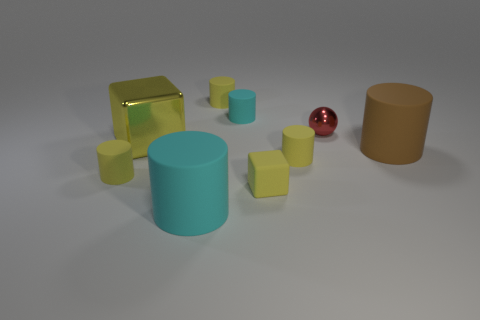Subtract all purple blocks. How many yellow cylinders are left? 3 Subtract all brown cylinders. How many cylinders are left? 5 Subtract all big brown cylinders. How many cylinders are left? 5 Subtract all gray cylinders. Subtract all red spheres. How many cylinders are left? 6 Add 1 small yellow matte things. How many objects exist? 10 Subtract all blocks. How many objects are left? 7 Subtract 0 yellow balls. How many objects are left? 9 Subtract all brown objects. Subtract all large yellow metal cubes. How many objects are left? 7 Add 4 tiny matte blocks. How many tiny matte blocks are left? 5 Add 3 big blocks. How many big blocks exist? 4 